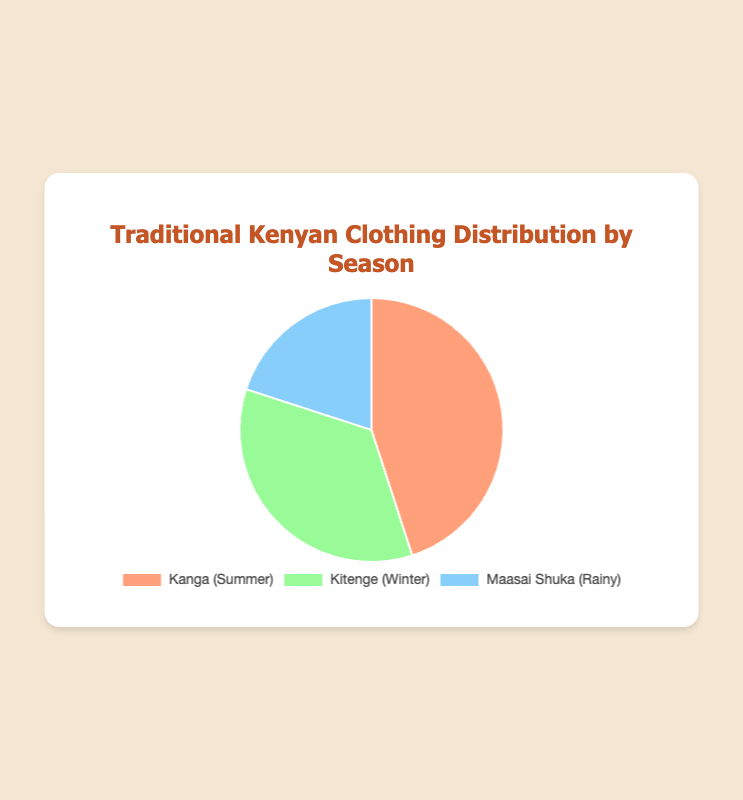What is the most commonly worn traditional clothing type during Summer? The segment representing "Kanga (Summer)" is the largest in the pie chart, indicating it has the highest percentage.
Answer: Kanga Which clothing type has the smallest representation in the pie chart, and what is the associated season? The smallest segment in the pie chart corresponds to "Maasai Shuka (Rainy)" which has the smallest percentage.
Answer: Maasai Shuka (Rainy) What is the combined percentage of traditional clothing types worn in Winter and Rainy seasons? The percentages for "Kitenge (Winter)" and "Maasai Shuka (Rainy)" are 35% and 20%, respectively. Adding them together gives (35 + 20) = 55%.
Answer: 55% How much more commonly is Kanga worn in Summer than Maasai Shuka in the Rainy season? Kanga is worn 45% of the time in Summer, while Maasai Shuka is worn 20% of the time in the Rainy season. The difference is (45 - 20) = 25%.
Answer: 25% What is the average percentage of the three traditional clothing types? The percentages are 45, 35, and 20. Summing these gives (45 + 35 + 20) = 100. Dividing by 3 gives (100 / 3) ≈ 33.33%
Answer: 33.33% Which traditional clothing type is represented by the green color? The green color corresponds to the segment labeled "Kitenge (Winter)" in the pie chart.
Answer: Kitenge By what percentage does Kitenge (Winter) surpass Maasai Shuka (Rainy)? Kitenge is worn 35% of the time during Winter, while Maasai Shuka is worn 20% in the Rainy season. The difference is (35 - 20) = 15%.
Answer: 15% Which traditional clothing type has a percentage closer to the average percentage of all three clothing types? The average percentage of all three clothing types is approximately 33.33%. "Kitenge (Winter)" has a percentage of 35%, which is closest to the average.
Answer: Kitenge What percentage of the pie chart is represented by Kanga's segment? The segment for Kanga is labeled with a percentage of 45%.
Answer: 45% Is the total percentage of all traditional clothing types in the pie chart equal to 100%? Adding the percentages for Kanga (45%), Kitenge (35%), and Maasai Shuka (20%) gives (45 + 35 + 20) = 100%.
Answer: Yes 